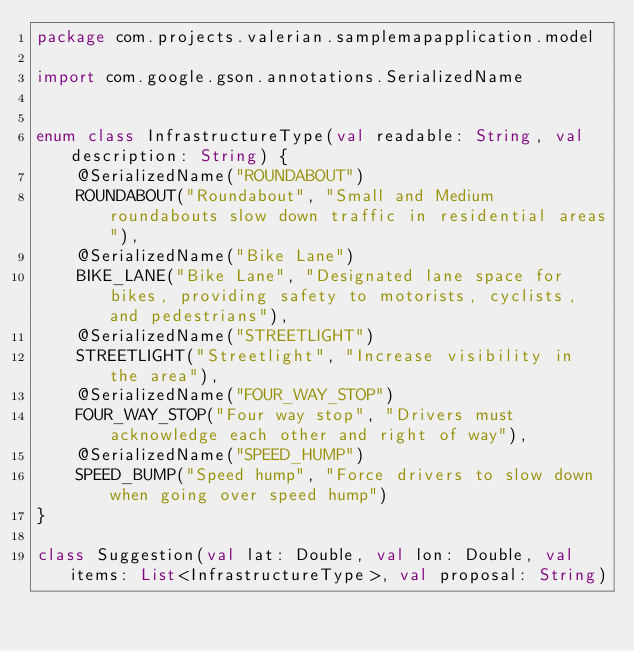<code> <loc_0><loc_0><loc_500><loc_500><_Kotlin_>package com.projects.valerian.samplemapapplication.model

import com.google.gson.annotations.SerializedName


enum class InfrastructureType(val readable: String, val description: String) {
    @SerializedName("ROUNDABOUT")
    ROUNDABOUT("Roundabout", "Small and Medium roundabouts slow down traffic in residential areas"),
    @SerializedName("Bike Lane")
    BIKE_LANE("Bike Lane", "Designated lane space for bikes, providing safety to motorists, cyclists, and pedestrians"),
    @SerializedName("STREETLIGHT")
    STREETLIGHT("Streetlight", "Increase visibility in the area"),
    @SerializedName("FOUR_WAY_STOP")
    FOUR_WAY_STOP("Four way stop", "Drivers must acknowledge each other and right of way"),
    @SerializedName("SPEED_HUMP")
    SPEED_BUMP("Speed hump", "Force drivers to slow down when going over speed hump")
}

class Suggestion(val lat: Double, val lon: Double, val items: List<InfrastructureType>, val proposal: String)</code> 